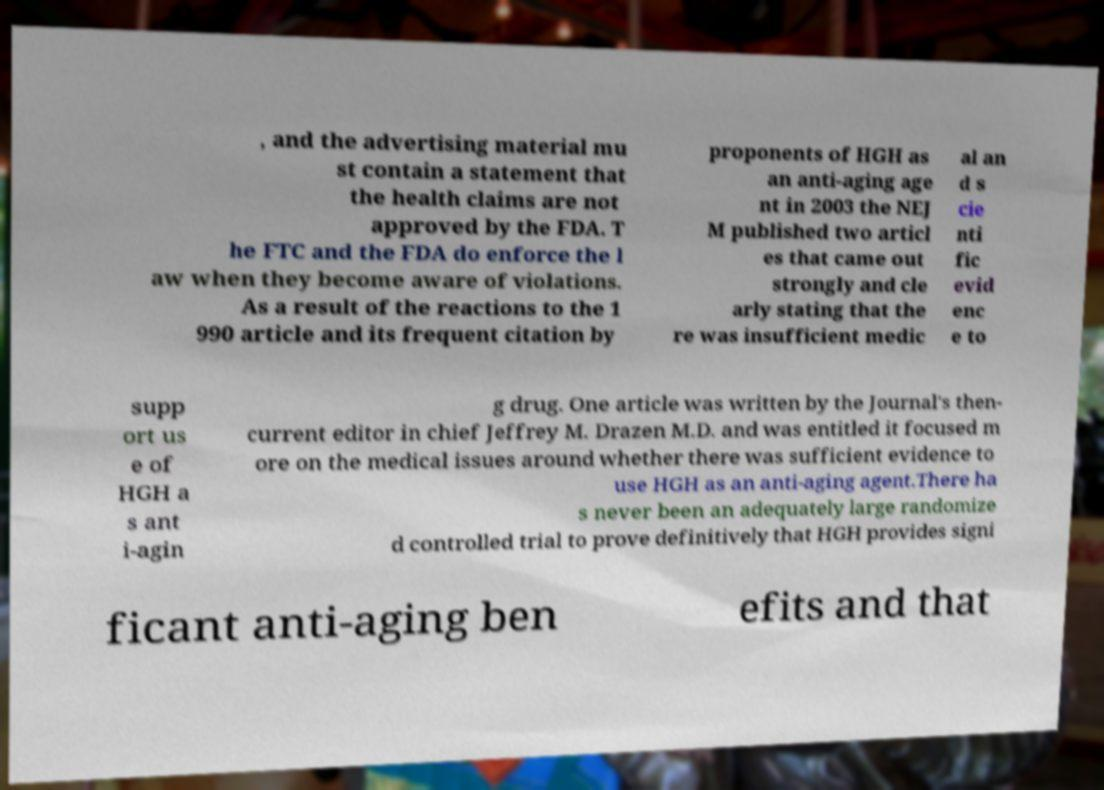Please read and relay the text visible in this image. What does it say? , and the advertising material mu st contain a statement that the health claims are not approved by the FDA. T he FTC and the FDA do enforce the l aw when they become aware of violations. As a result of the reactions to the 1 990 article and its frequent citation by proponents of HGH as an anti-aging age nt in 2003 the NEJ M published two articl es that came out strongly and cle arly stating that the re was insufficient medic al an d s cie nti fic evid enc e to supp ort us e of HGH a s ant i-agin g drug. One article was written by the Journal's then- current editor in chief Jeffrey M. Drazen M.D. and was entitled it focused m ore on the medical issues around whether there was sufficient evidence to use HGH as an anti-aging agent.There ha s never been an adequately large randomize d controlled trial to prove definitively that HGH provides signi ficant anti-aging ben efits and that 